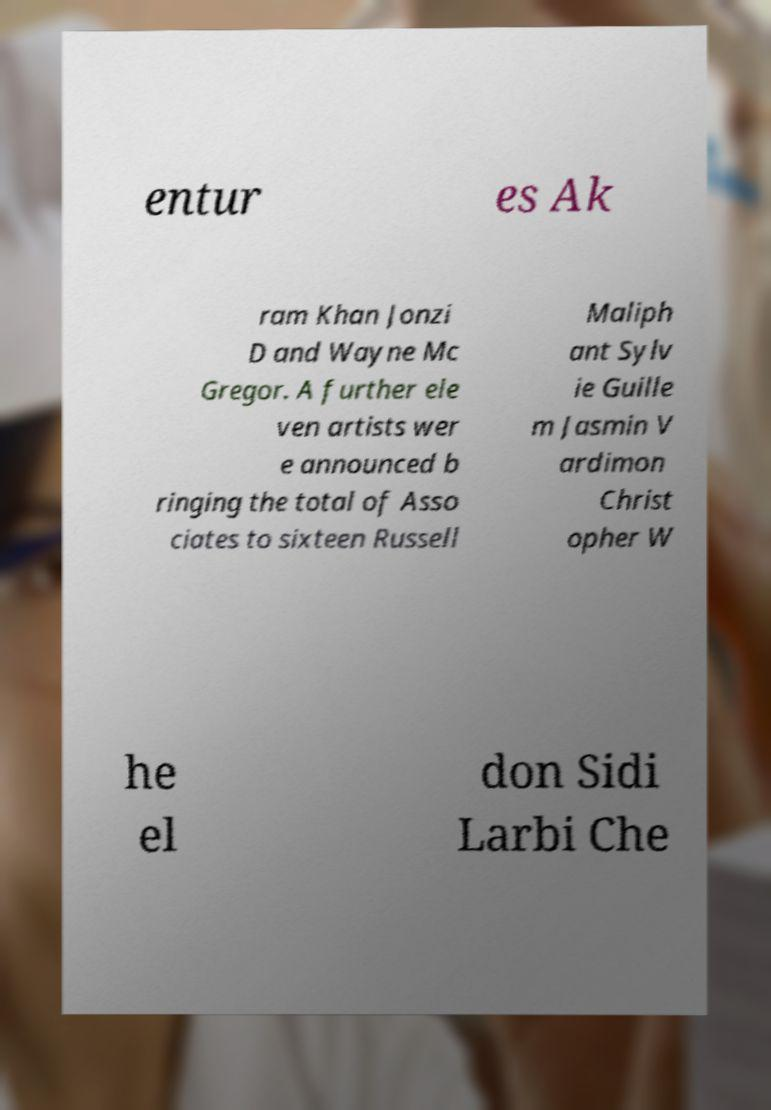What messages or text are displayed in this image? I need them in a readable, typed format. entur es Ak ram Khan Jonzi D and Wayne Mc Gregor. A further ele ven artists wer e announced b ringing the total of Asso ciates to sixteen Russell Maliph ant Sylv ie Guille m Jasmin V ardimon Christ opher W he el don Sidi Larbi Che 